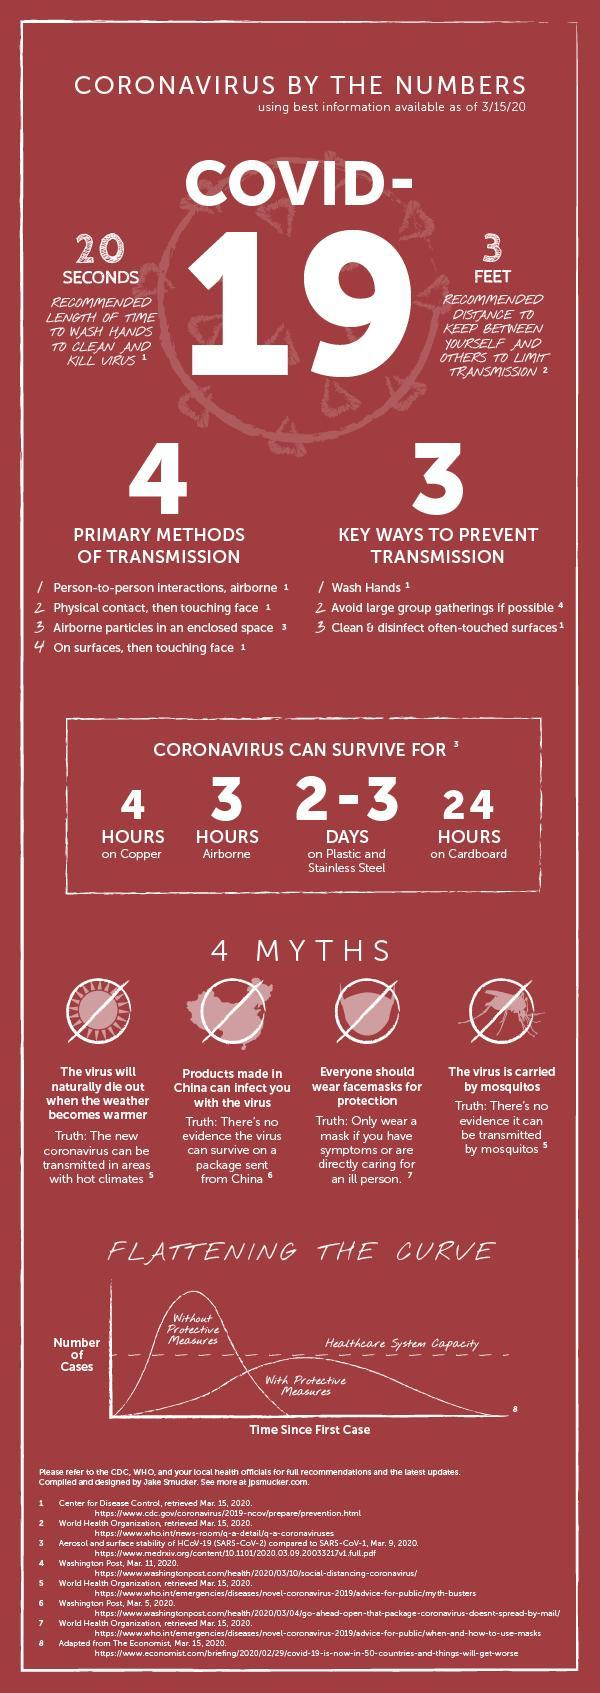On which surface can corona virus survive for one day?
Answer the question with a short phrase. Cardboard 